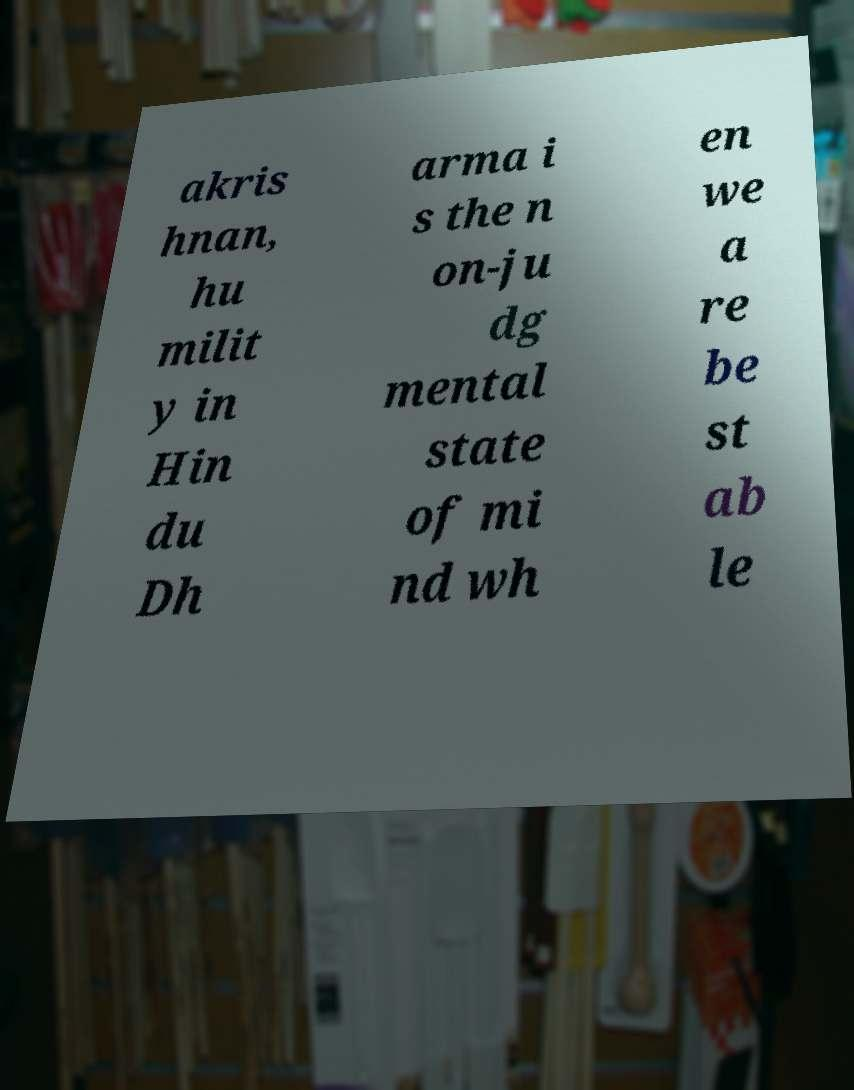Can you read and provide the text displayed in the image?This photo seems to have some interesting text. Can you extract and type it out for me? akris hnan, hu milit y in Hin du Dh arma i s the n on-ju dg mental state of mi nd wh en we a re be st ab le 